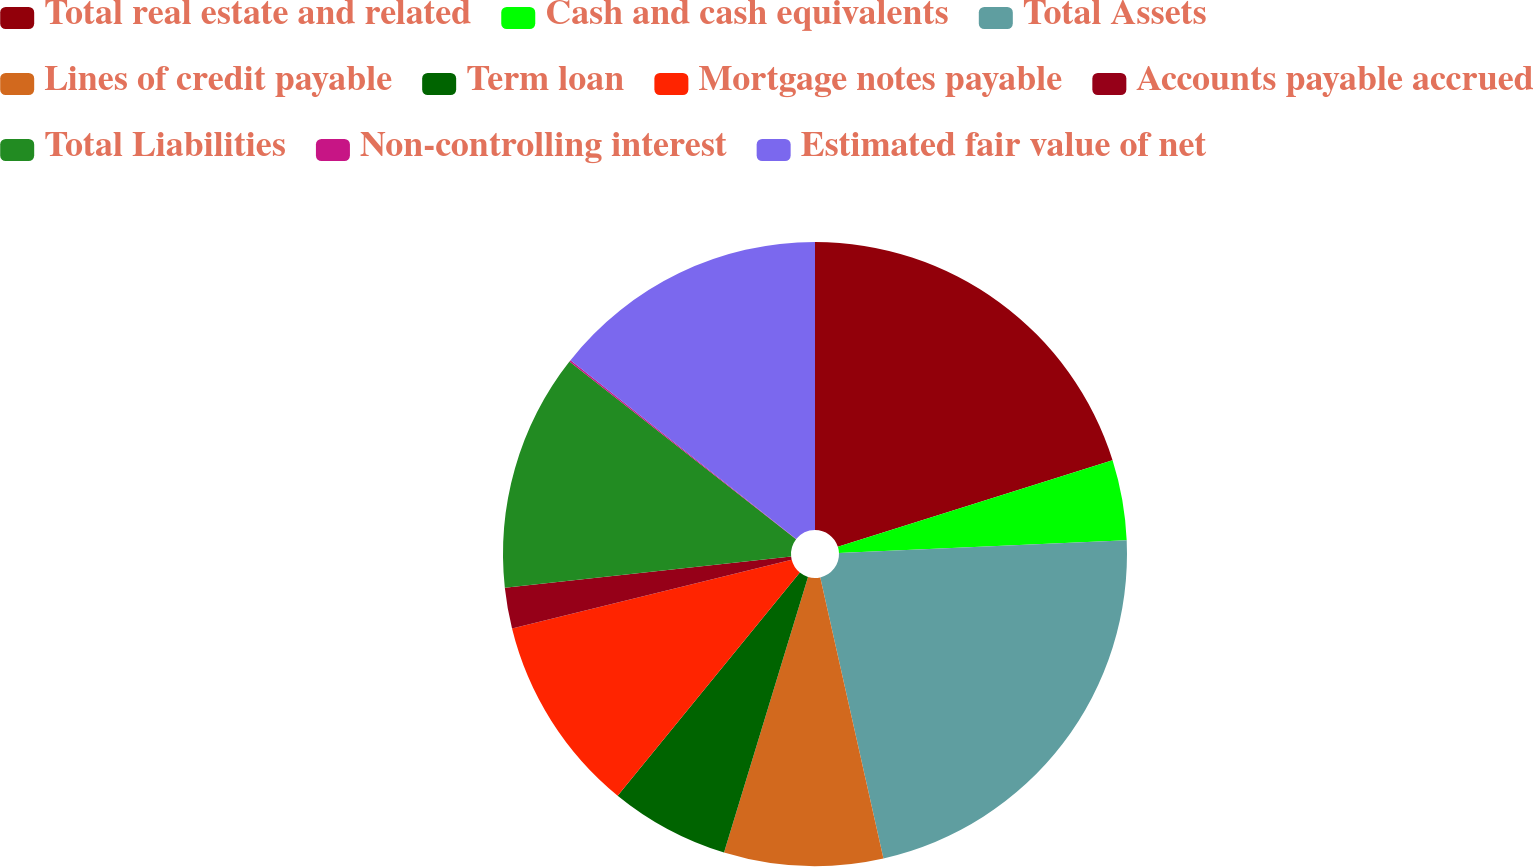Convert chart. <chart><loc_0><loc_0><loc_500><loc_500><pie_chart><fcel>Total real estate and related<fcel>Cash and cash equivalents<fcel>Total Assets<fcel>Lines of credit payable<fcel>Term loan<fcel>Mortgage notes payable<fcel>Accounts payable accrued<fcel>Total Liabilities<fcel>Non-controlling interest<fcel>Estimated fair value of net<nl><fcel>20.14%<fcel>4.16%<fcel>22.18%<fcel>8.23%<fcel>6.19%<fcel>10.26%<fcel>2.12%<fcel>12.3%<fcel>0.09%<fcel>14.33%<nl></chart> 